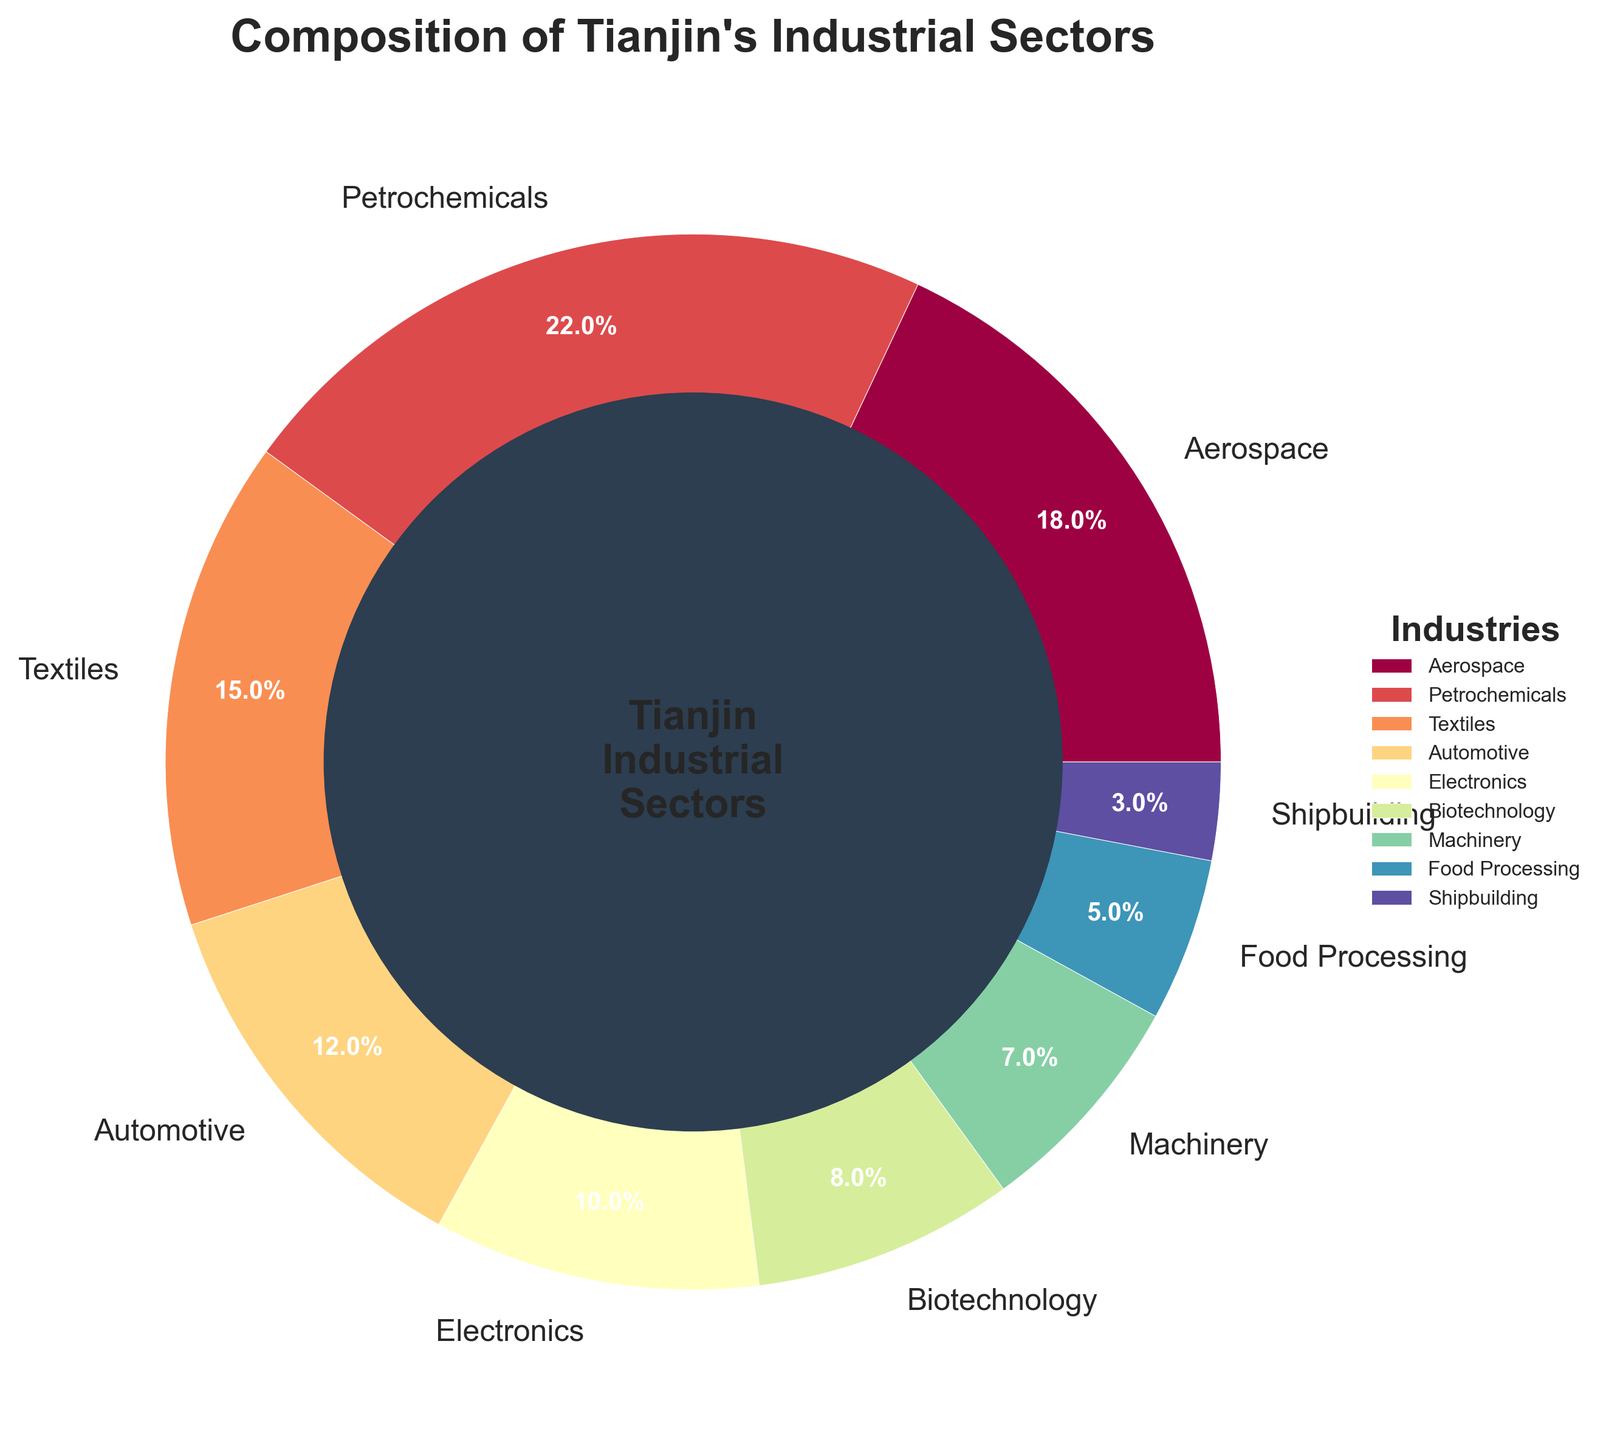Which industrial sector has the highest percentage? The figure shows different industrial sectors with their respective percentages around the pie. The sector with the highest percentage has the largest slice.
Answer: Petrochemicals What is the total percentage of the Aerospace and Textiles sectors? Adding the percentages of the Aerospace (18%) and the Textiles (15%) sectors results in the total percentage for these two sectors. 18% + 15% = 33%
Answer: 33% How does the percentage of the Biotechnology sector compare to the Electronics sector? The Biotechnology sector has a percentage of 8%, while the Electronics sector has a percentage of 10%. Comparing these two, the Electronics sector has a higher percentage.
Answer: Electronics is higher by 2% What is the difference in percentage between the Petrochemicals sector and the Shipbuilding sector? Subtract the percentage of the Shipbuilding sector (3%) from the percentage of the Petrochemicals sector (22%). 22% - 3% = 19%
Answer: 19% Which sectors have equal or less than 10% each? By observing each sector's percentage, we can identify those that are 10% or less: Electronics (10%), Biotechnology (8%), Machinery (7%), Food Processing (5%), and Shipbuilding (3%).
Answer: Electronics, Biotechnology, Machinery, Food Processing, Shipbuilding What is the combined percentage of the top three sectors? The top three sectors are identified by their largest slices: Petrochemicals (22%), Aerospace (18%), and Textiles (15%). Adding them together gives 22% + 18% + 15% = 55%.
Answer: 55% How many sectors have a percentage greater than or equal to 15%? Identifying the sectors with percentages 15% or more: Petrochemicals (22%), Aerospace (18%), Textiles (15%). There are three such sectors.
Answer: 3 Which sector has a visual center circle color, and what is this color? There is a distinctive central circle within the pie chart. The color of this central circle is noted visually.
Answer: #2C3E50 (Denoted color) What is the percentage range covered by all the sectors in the figure? The highest percentage is from Petrochemicals (22%), and the lowest is from Shipbuilding (3%). Therefore, the range is calculated as 22% - 3%.
Answer: 19% What would be the impact on the pie chart if the percentage of the Food Processing sector increased to 12%? To understand the impact, we should consider the relative and absolute differences caused by increasing from 5% to 12%. This change will increase the slice size for Food Processing and decrease the proportions of other sectors.
Answer: Larger Food Processing slice, smaller slices for others 